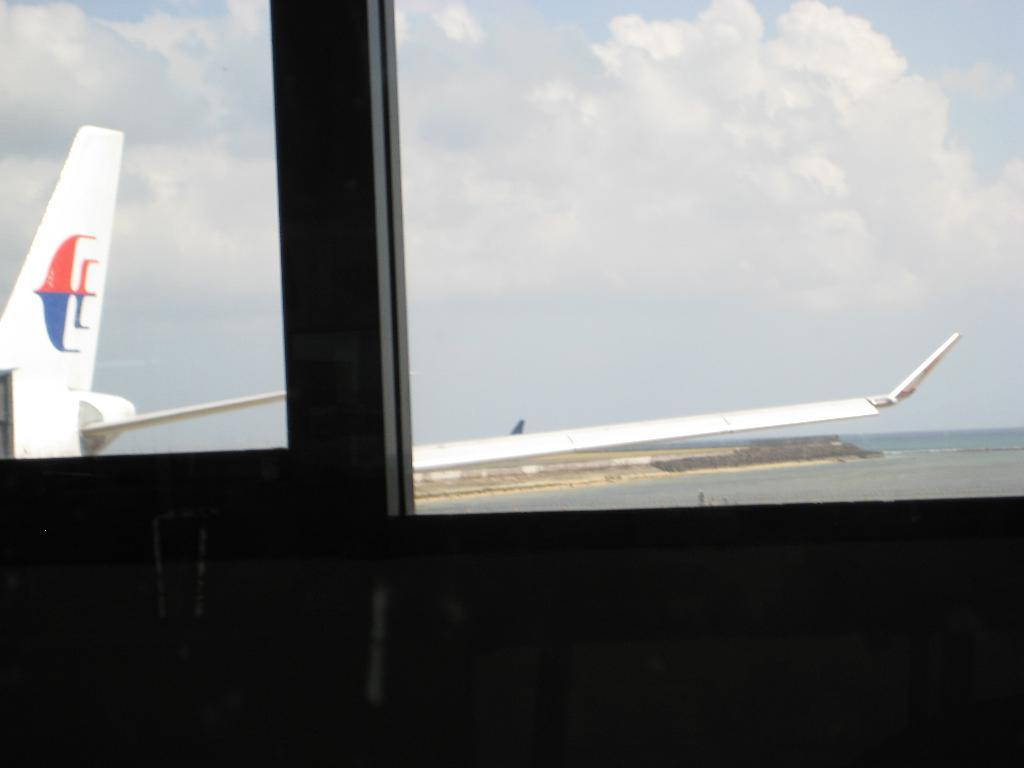What can be seen through the window in the image? An aeroplane is visible through the window in the image. What are the colors of the aeroplane? The aeroplane is white, red, and blue in color. What is visible in the background of the image? The sky, water, and ground are visible in the background of the image. Where is the maid standing with the pot in the image? There is no maid or pot present in the image. What type of line can be seen connecting the aeroplane to the ground in the image? There is no line connecting the aeroplane to the ground in the image. 